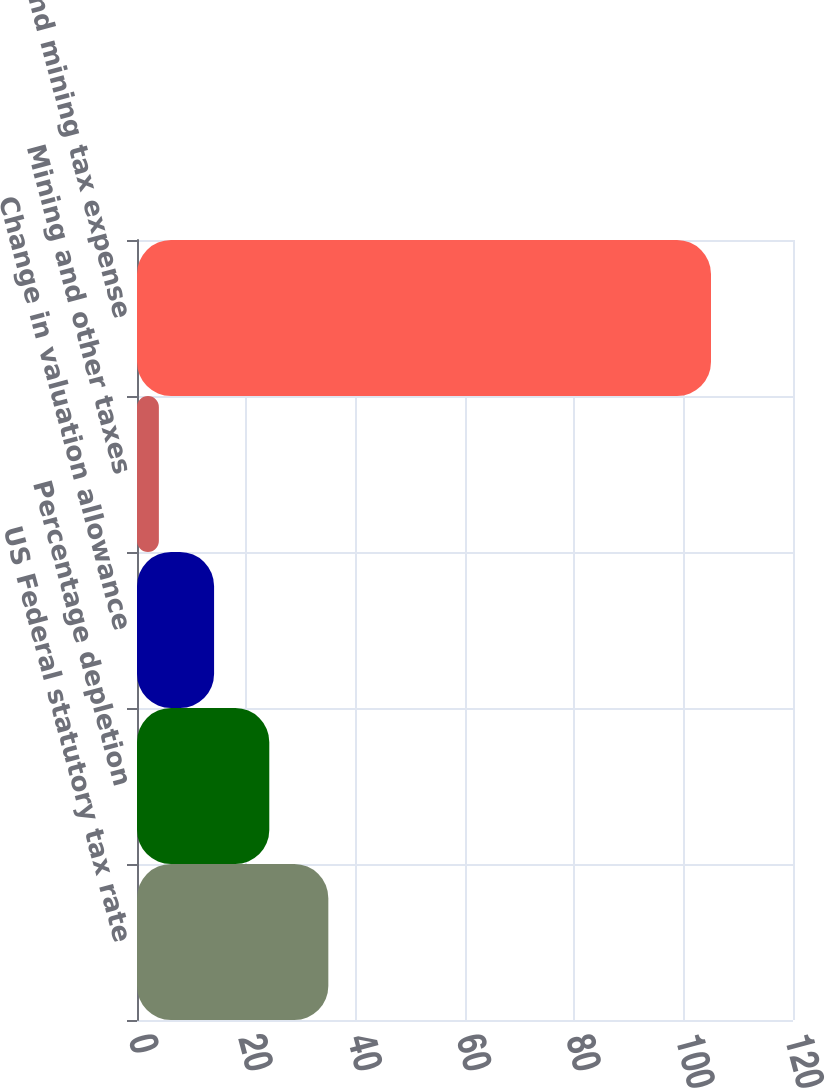Convert chart. <chart><loc_0><loc_0><loc_500><loc_500><bar_chart><fcel>US Federal statutory tax rate<fcel>Percentage depletion<fcel>Change in valuation allowance<fcel>Mining and other taxes<fcel>Income and mining tax expense<nl><fcel>35<fcel>24.2<fcel>14.1<fcel>4<fcel>105<nl></chart> 